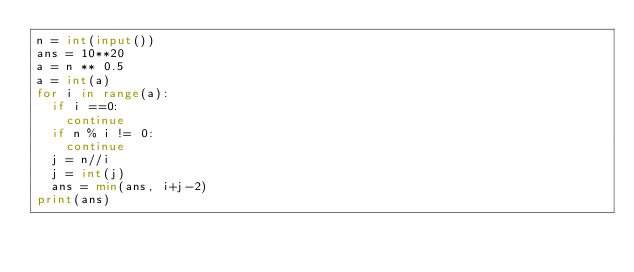Convert code to text. <code><loc_0><loc_0><loc_500><loc_500><_Python_>n = int(input())
ans = 10**20
a = n ** 0.5
a = int(a)
for i in range(a):
  if i ==0:
    continue
  if n % i != 0:
    continue
  j = n//i
  j = int(j)
  ans = min(ans, i+j-2)
print(ans)</code> 